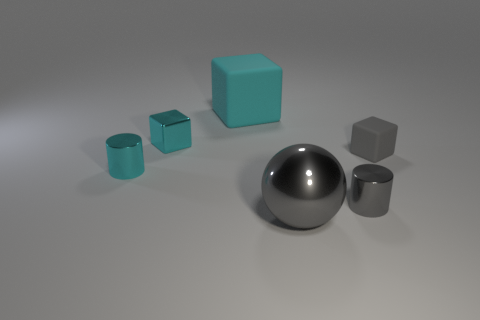Does the large metal object have the same color as the tiny matte block?
Keep it short and to the point. Yes. There is a small block to the left of the small gray block that is behind the gray sphere; are there any small things right of it?
Your response must be concise. Yes. There is a gray thing that is right of the ball and in front of the tiny gray matte object; what is its shape?
Offer a very short reply. Cylinder. Are there any tiny objects of the same color as the sphere?
Your response must be concise. Yes. What is the color of the matte cube left of the block that is right of the big cyan thing?
Make the answer very short. Cyan. What is the size of the cylinder to the right of the tiny metallic cylinder that is on the left side of the large object behind the big gray metallic sphere?
Ensure brevity in your answer.  Small. Is the material of the gray cylinder the same as the tiny cube left of the cyan rubber block?
Your response must be concise. Yes. The sphere that is made of the same material as the cyan cylinder is what size?
Your answer should be very brief. Large. Is there another gray thing that has the same shape as the tiny gray metal object?
Keep it short and to the point. No. How many objects are tiny gray blocks on the right side of the small gray metal thing or cylinders?
Offer a terse response. 3. 